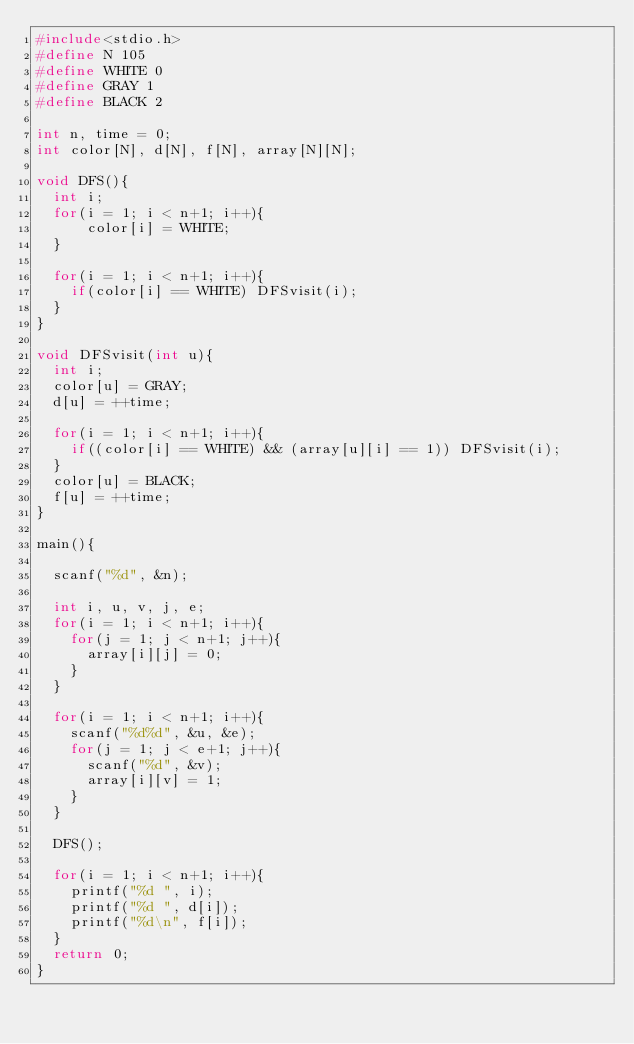Convert code to text. <code><loc_0><loc_0><loc_500><loc_500><_C_>#include<stdio.h>
#define N 105
#define WHITE 0
#define GRAY 1
#define BLACK 2

int n, time = 0;
int color[N], d[N], f[N], array[N][N];

void DFS(){
  int i;
  for(i = 1; i < n+1; i++){
      color[i] = WHITE;
  }

  for(i = 1; i < n+1; i++){
    if(color[i] == WHITE) DFSvisit(i);
  }
}

void DFSvisit(int u){
  int i;
  color[u] = GRAY;
  d[u] = ++time;
  
  for(i = 1; i < n+1; i++){
    if((color[i] == WHITE) && (array[u][i] == 1)) DFSvisit(i);
  }
  color[u] = BLACK;
  f[u] = ++time;
}

main(){

  scanf("%d", &n);

  int i, u, v, j, e;
  for(i = 1; i < n+1; i++){
    for(j = 1; j < n+1; j++){
      array[i][j] = 0;
    }
  }

  for(i = 1; i < n+1; i++){
    scanf("%d%d", &u, &e);
    for(j = 1; j < e+1; j++){
      scanf("%d", &v);
      array[i][v] = 1;
    }
  }

  DFS();
  
  for(i = 1; i < n+1; i++){
    printf("%d ", i);
    printf("%d ", d[i]);
    printf("%d\n", f[i]);
  }
  return 0;
}</code> 